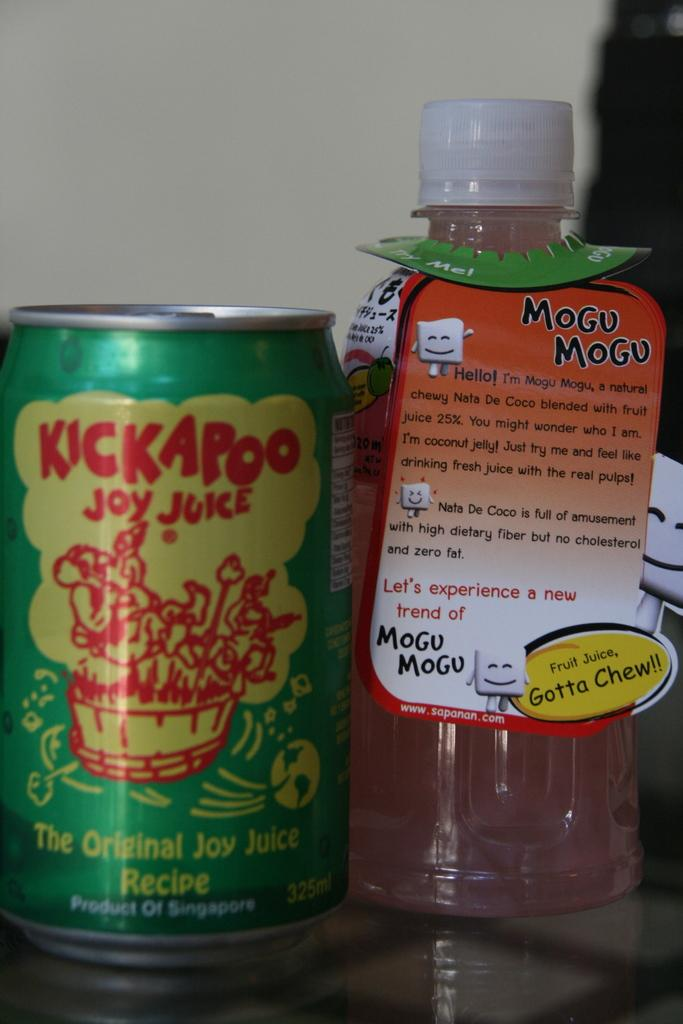<image>
Provide a brief description of the given image. A can of Kickapoo Joy Juice next to a bottle of Mogu Mogu. 